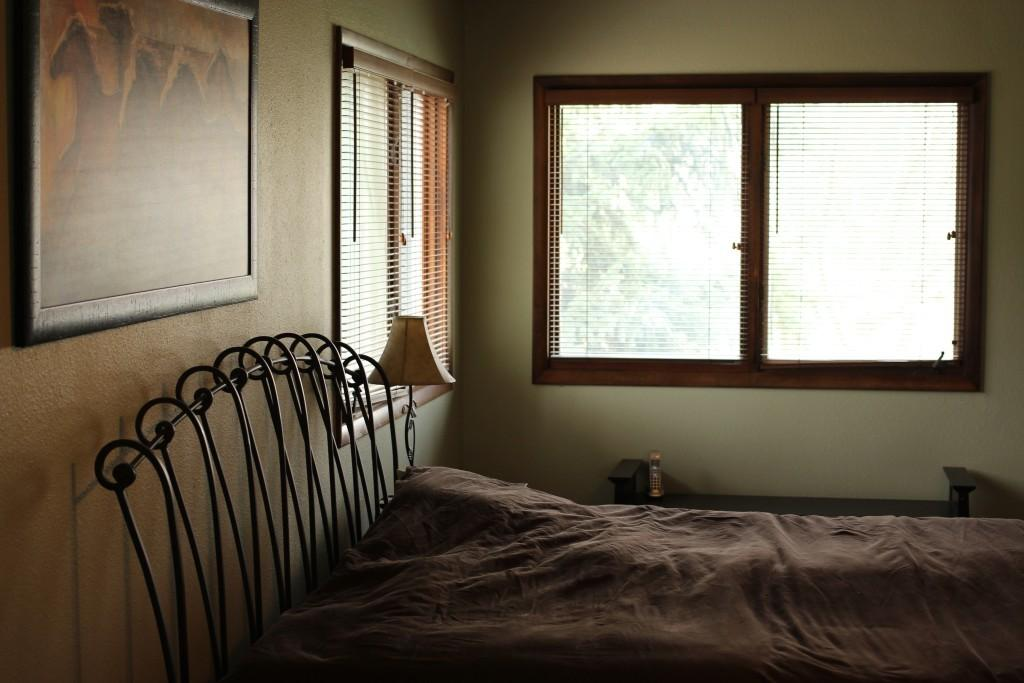What is located at the bottom of the image? There is a bed at the bottom of the image. What object is on the bed? There is a bed lamp on the bed. What can be seen in the middle of the image? There are windows in the middle of the image. Where is the photo frame located in the image? The photo frame is on the wall on the left side. What type of jam is on the table in the image? There is no table present in the image. 